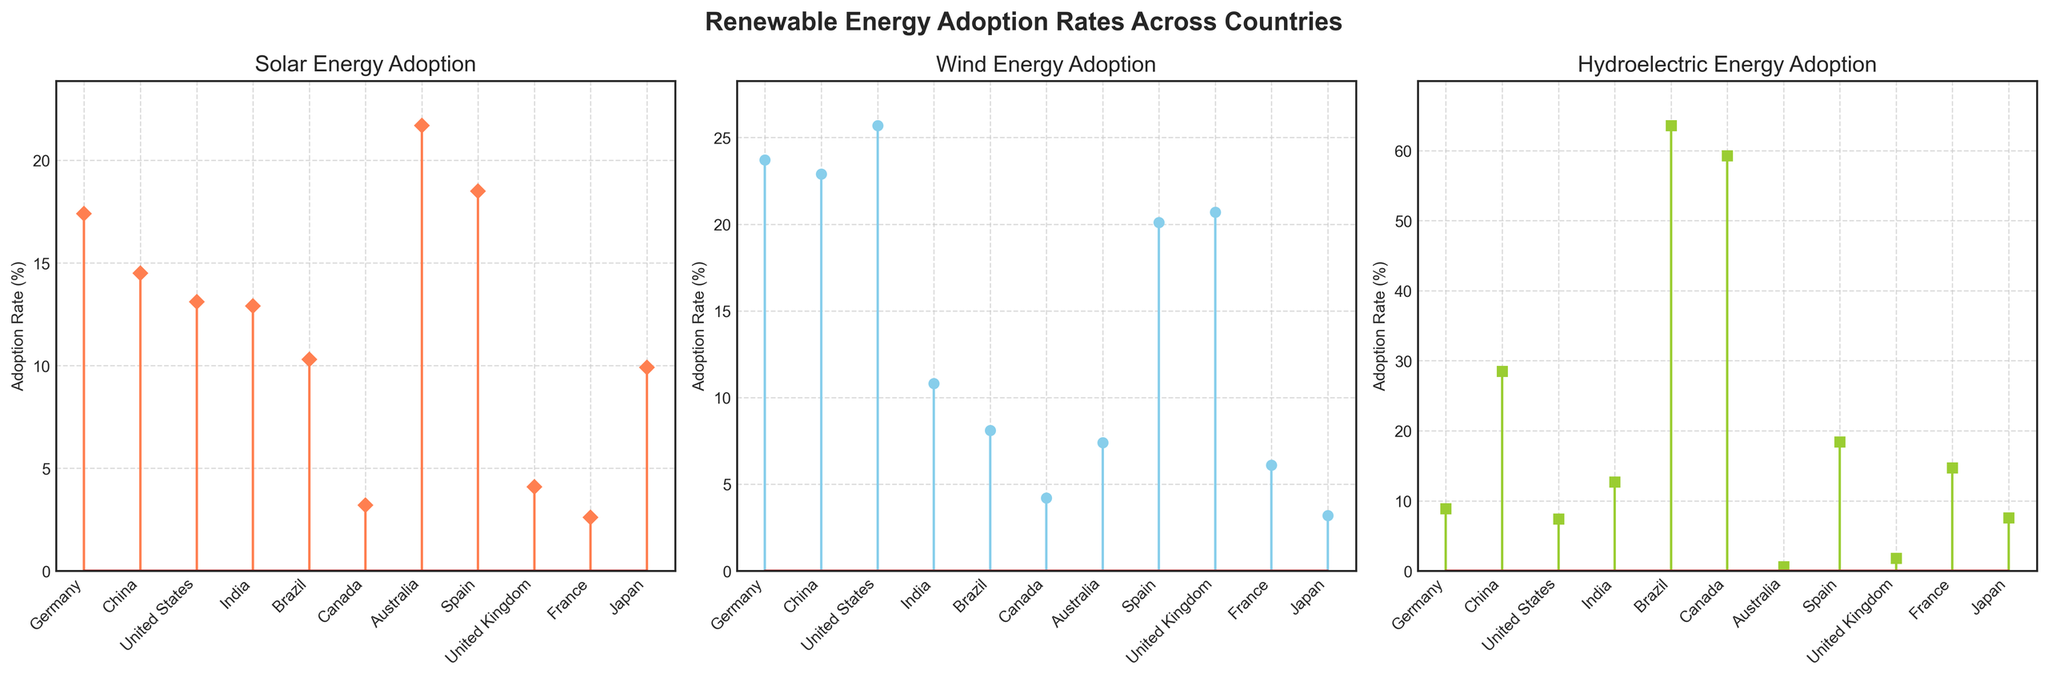Which country has the highest adoption rate for solar energy? The subplot for solar energy adoption indicates that Australia has the highest stem height, representing an adoption rate of 21.7%.
Answer: Australia Which country has the lowest adoption rate for wind energy? Reviewing the wind energy adoption subplot, Japan has the smallest stem, representing an adoption rate of 3.2%.
Answer: Japan How many countries have a hydroelectric adoption rate above 50%? From the hydroelectric energy adoption subplot, Brazil and Canada have adoption rates above 50%.
Answer: 2 What is the average adoption rate of solar energy across all countries? Summing all solar adoption rates: 17.4 + 14.5 + 13.1 + 12.9 + 10.3 + 3.2 + 21.7 + 18.5 + 4.1 + 2.6 + 9.9 = 128.2. Dividing by 11 (the number of countries) gives an average of 128.2 / 11 ≈ 11.65%.
Answer: ~11.65% Which country has a higher adoption rate of hydroelectric energy: India or France? Referring to the hydroelectric subplot, India’s adoption rate is 12.7%, whereas France’s is 14.7%, thus, France has a higher rate.
Answer: France Compare the wind energy adoption rates of Germany and Spain. Which is greater, and by how much? Germany’s wind energy adoption rate is 23.7%, and Spain's is 20.1%. The difference is 23.7 - 20.1 = 3.6%. Therefore, Germany's rate is greater by 3.6%.
Answer: Germany, 3.6% What is the total adoption rate of hydroelectric energy for Brazil and Canada combined? Brazil’s hydroelectric rate is 63.6%, and Canada’s is 59.3%. Combined, they are 63.6 + 59.3 = 122.9%.
Answer: 122.9% Which country has a higher rate of solar energy adoption compared to its wind energy adoption rate? Referencing both the solar and wind subplots, Australia (21.7% solar vs 7.4% wind) and Spain (18.5% solar vs 20.1% wind) are compared; only Australia has a higher solar rate.
Answer: Australia 